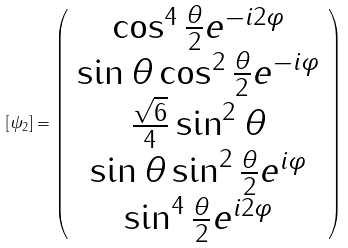<formula> <loc_0><loc_0><loc_500><loc_500>[ \psi _ { 2 } ] = \left ( \begin{array} { c } \cos ^ { 4 } \frac { \theta } { 2 } e ^ { - i 2 \varphi } \\ \sin \theta \cos ^ { 2 } \frac { \theta } { 2 } e ^ { - i \varphi } \\ \frac { \sqrt { 6 } } 4 \sin ^ { 2 } \theta \\ \sin \theta \sin ^ { 2 } \frac { \theta } { 2 } e ^ { i \varphi } \\ \sin ^ { 4 } \frac { \theta } { 2 } e ^ { i 2 \varphi } \end{array} \right )</formula> 